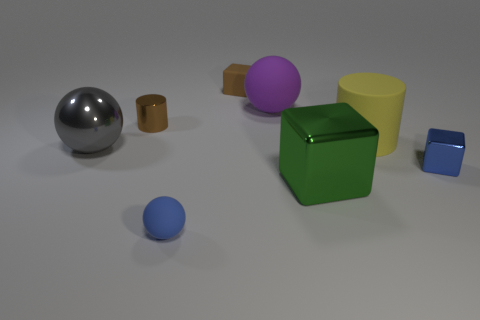Subtract 1 balls. How many balls are left? 2 Subtract all small rubber blocks. How many blocks are left? 2 Add 1 large brown rubber objects. How many objects exist? 9 Subtract all spheres. How many objects are left? 5 Add 7 purple balls. How many purple balls exist? 8 Subtract 0 yellow cubes. How many objects are left? 8 Subtract all tiny gray shiny objects. Subtract all metallic spheres. How many objects are left? 7 Add 6 purple objects. How many purple objects are left? 7 